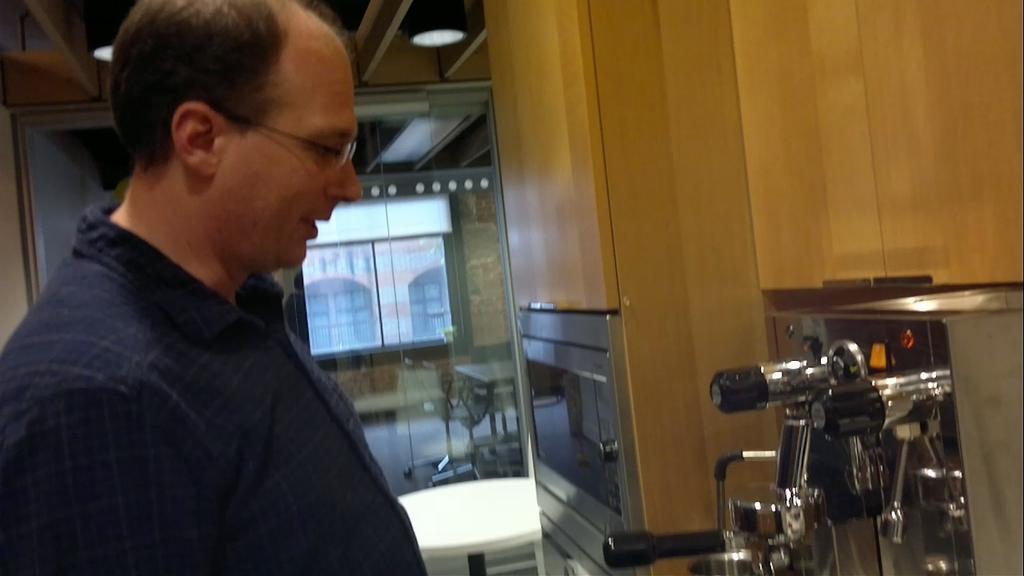Describe this image in one or two sentences. In this image we can see a man standing in front of a machine. We can also see an oven and a wooden wall. We can also see some tables and chairs on the floor, a window, wall and some ceiling lights to a roof. 